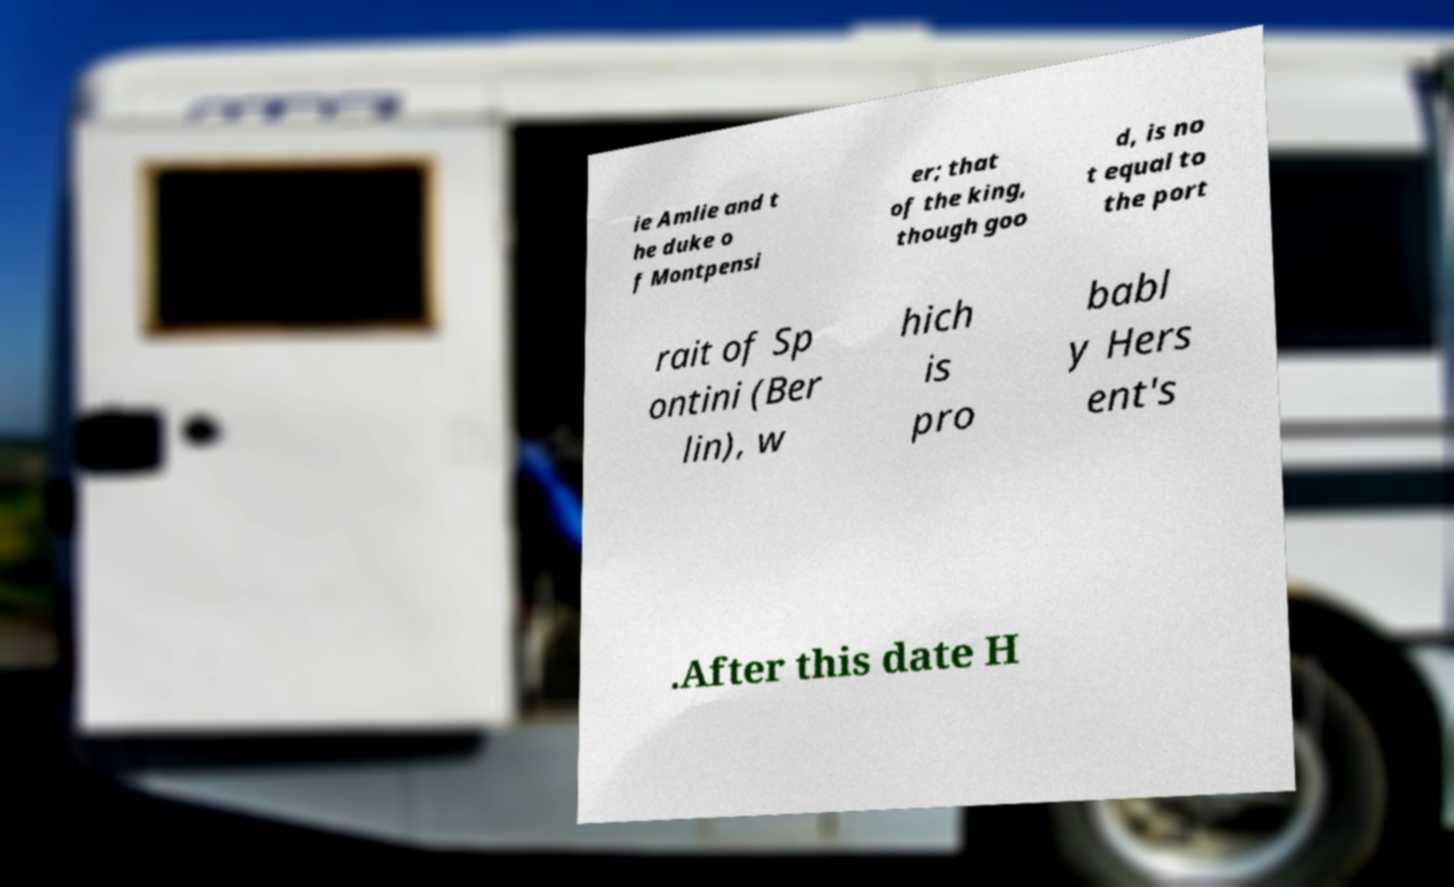I need the written content from this picture converted into text. Can you do that? ie Amlie and t he duke o f Montpensi er; that of the king, though goo d, is no t equal to the port rait of Sp ontini (Ber lin), w hich is pro babl y Hers ent's .After this date H 